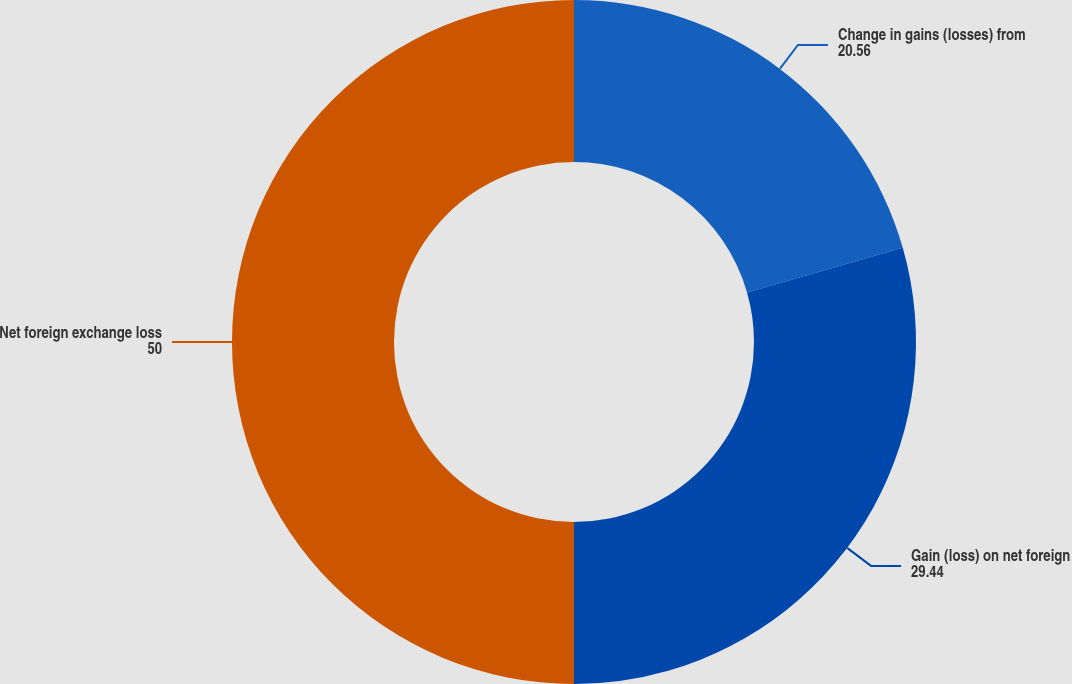<chart> <loc_0><loc_0><loc_500><loc_500><pie_chart><fcel>Change in gains (losses) from<fcel>Gain (loss) on net foreign<fcel>Net foreign exchange loss<nl><fcel>20.56%<fcel>29.44%<fcel>50.0%<nl></chart> 